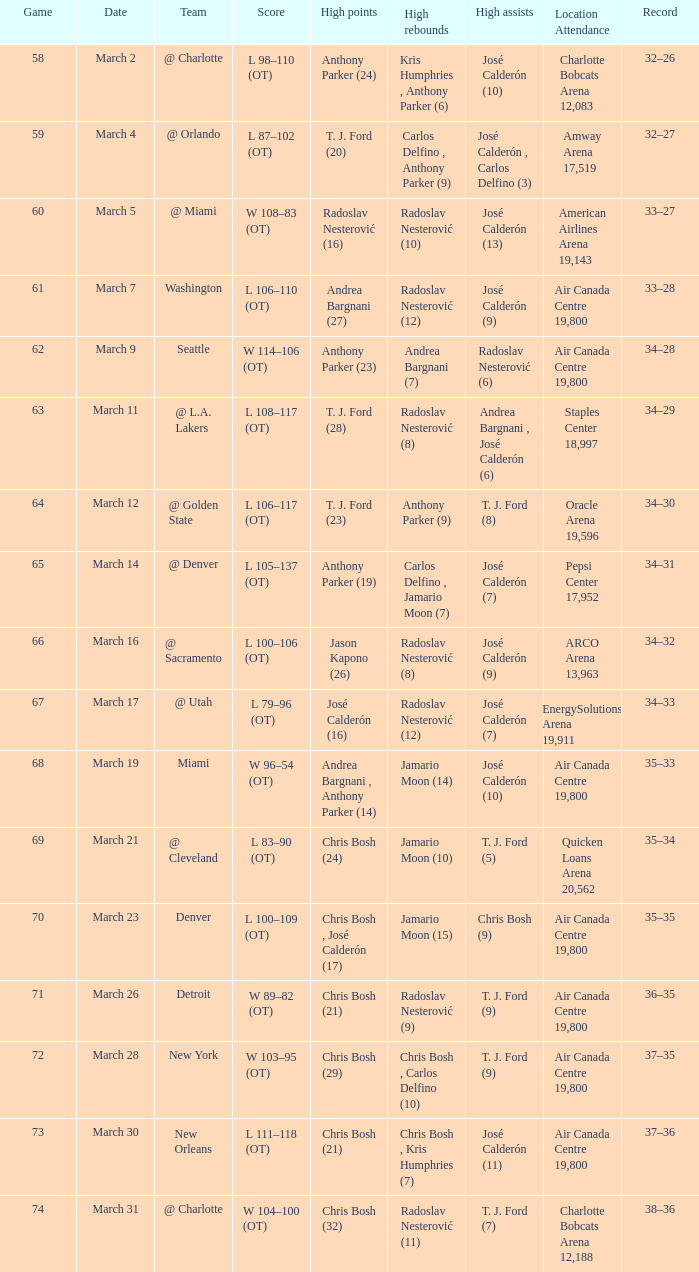In which numbered game did radoslav nesterović achieve 8 high rebounds and josé calderón have 9 high assists? 1.0. 